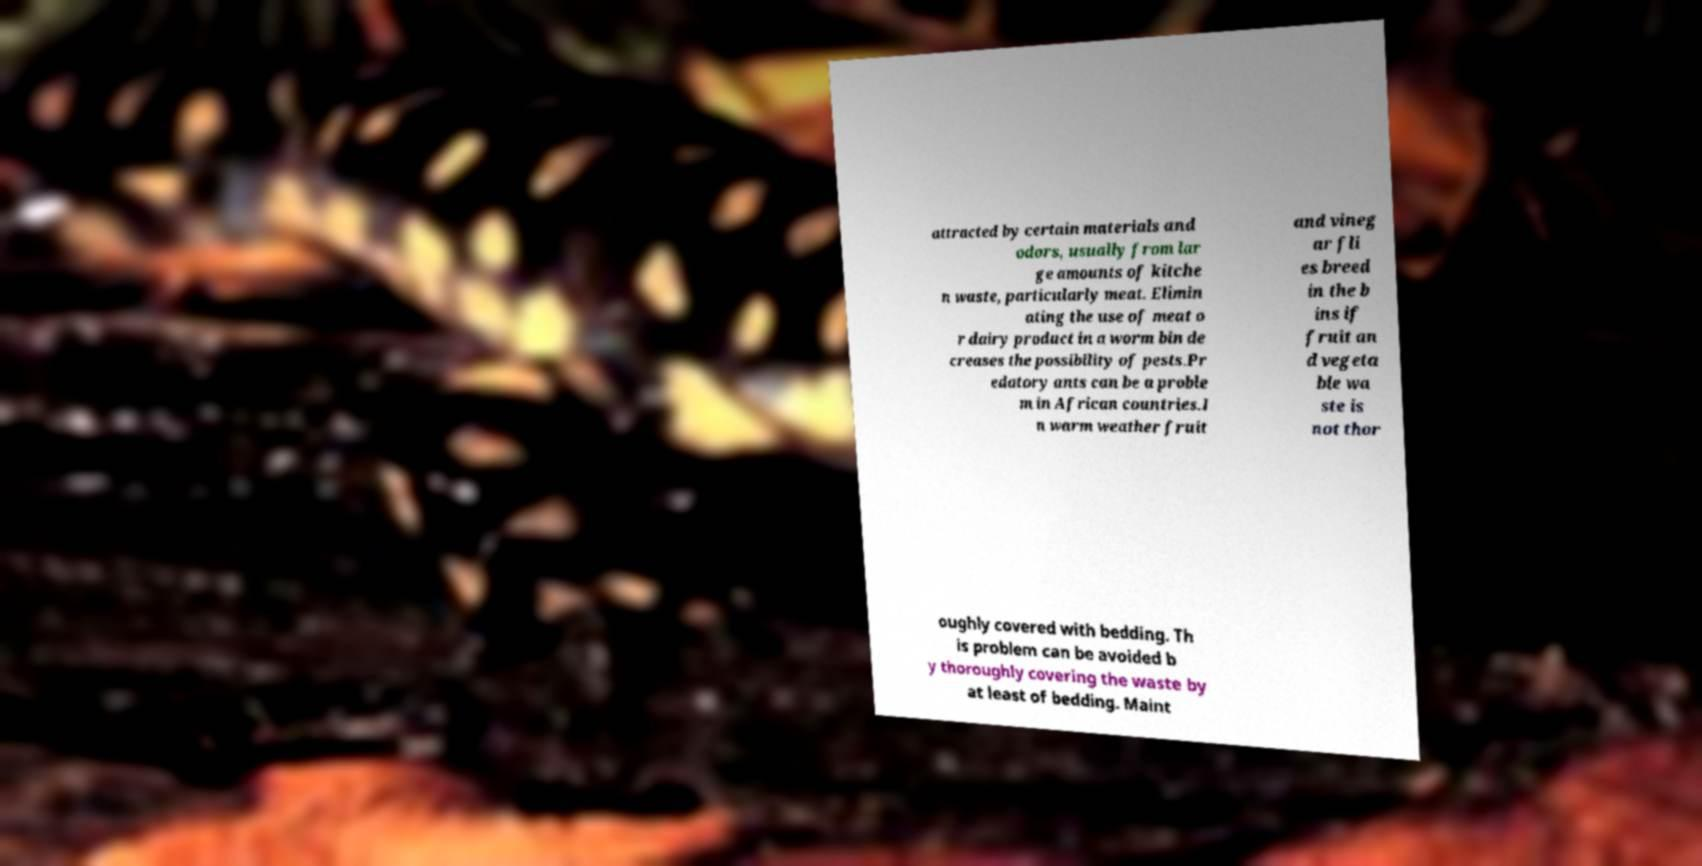There's text embedded in this image that I need extracted. Can you transcribe it verbatim? attracted by certain materials and odors, usually from lar ge amounts of kitche n waste, particularly meat. Elimin ating the use of meat o r dairy product in a worm bin de creases the possibility of pests.Pr edatory ants can be a proble m in African countries.I n warm weather fruit and vineg ar fli es breed in the b ins if fruit an d vegeta ble wa ste is not thor oughly covered with bedding. Th is problem can be avoided b y thoroughly covering the waste by at least of bedding. Maint 